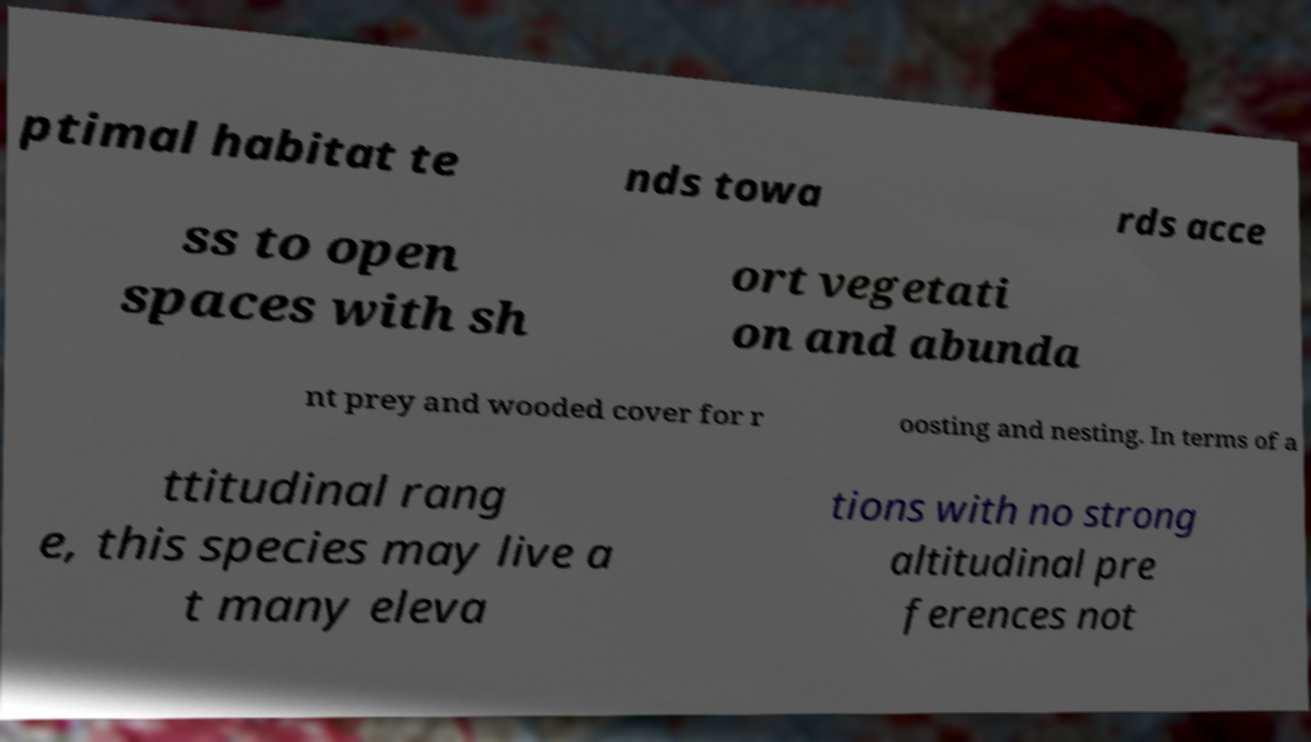There's text embedded in this image that I need extracted. Can you transcribe it verbatim? ptimal habitat te nds towa rds acce ss to open spaces with sh ort vegetati on and abunda nt prey and wooded cover for r oosting and nesting. In terms of a ttitudinal rang e, this species may live a t many eleva tions with no strong altitudinal pre ferences not 